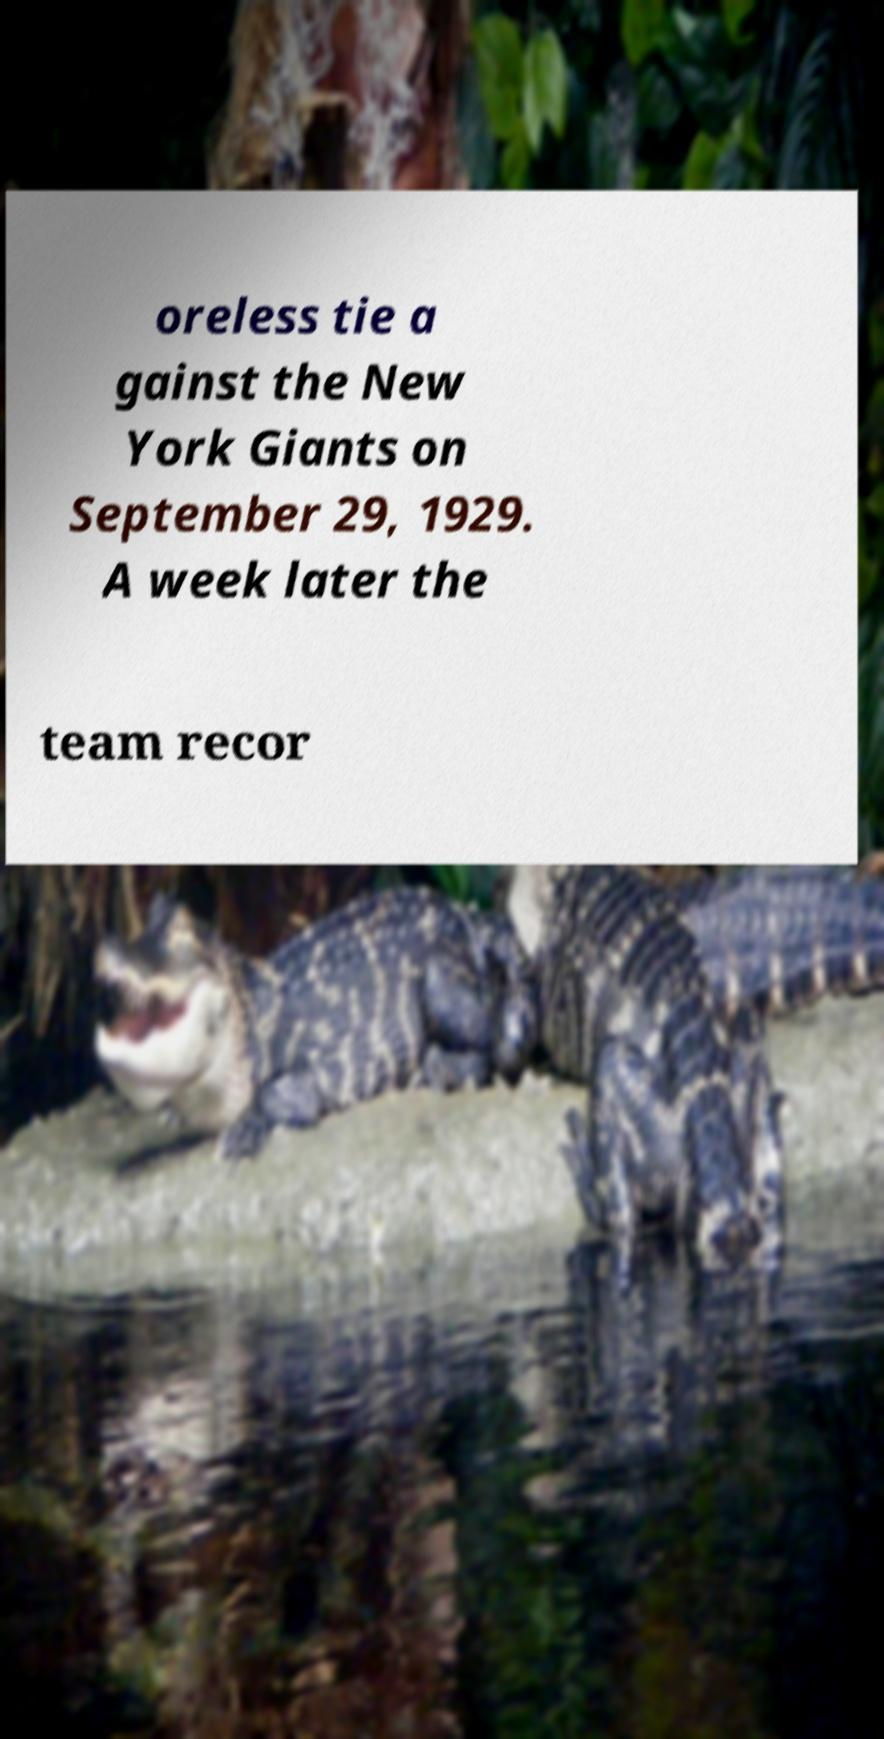Please identify and transcribe the text found in this image. oreless tie a gainst the New York Giants on September 29, 1929. A week later the team recor 